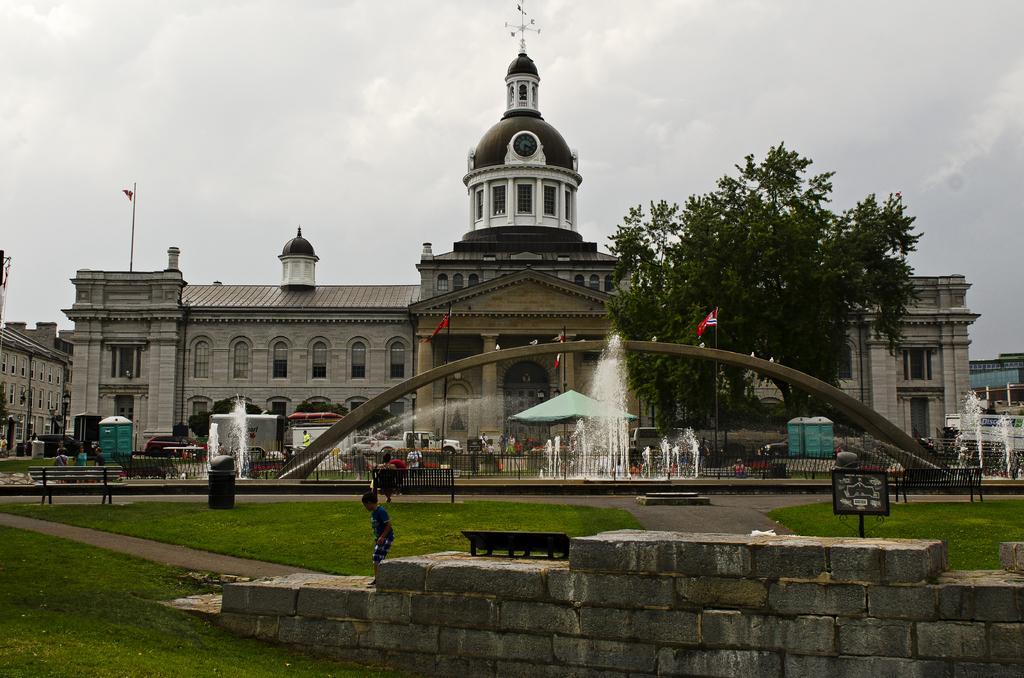In one or two sentences, can you explain what this image depicts? In this image there are people. There are benches, dustbins, buildings, trees, flags, fountains, vehicles and a metal fence. In the center of the image there is a tent. At the bottom of the image there is grass on the surface. At the top of the image there is sky. 